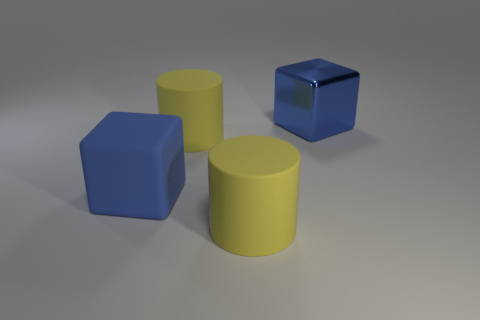Do the large matte cube and the large shiny block have the same color?
Your answer should be very brief. Yes. Is there any other thing that is the same color as the large metallic thing?
Your answer should be compact. Yes. Is the shape of the blue thing in front of the big blue metallic block the same as the big object in front of the large blue rubber thing?
Offer a terse response. No. What number of things are small blue matte balls or yellow cylinders behind the large rubber cube?
Your answer should be compact. 1. What number of other objects are there of the same size as the blue metal block?
Keep it short and to the point. 3. Do the yellow cylinder that is behind the blue rubber block and the large blue block that is in front of the big metallic block have the same material?
Your answer should be very brief. Yes. There is a large blue matte object; how many large yellow rubber things are left of it?
Provide a succinct answer. 0. How many brown things are shiny things or cubes?
Give a very brief answer. 0. What is the material of the blue thing that is the same size as the blue metallic cube?
Make the answer very short. Rubber. There is a matte cube that is the same size as the metallic thing; what color is it?
Ensure brevity in your answer.  Blue. 